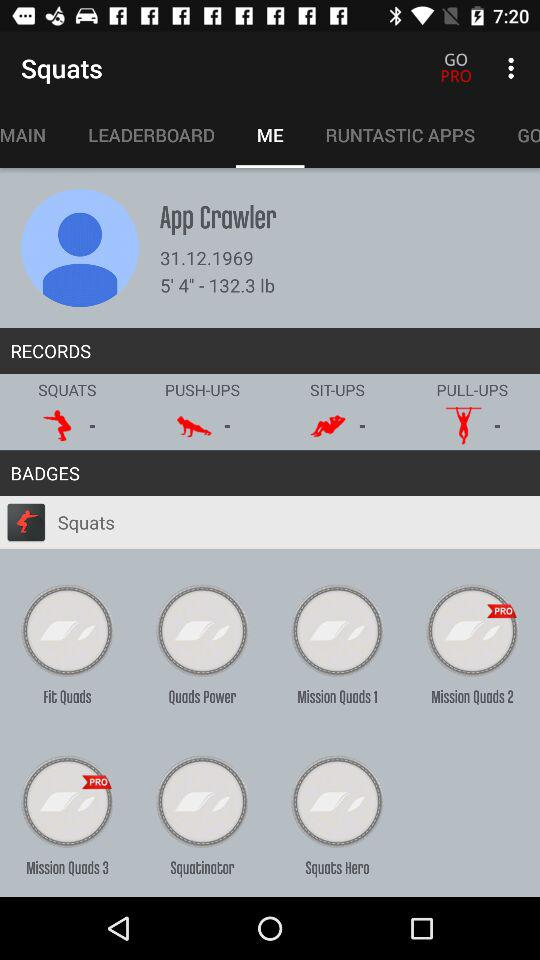What's the height of the user? The height of the user is 5 feet 4 inches. 